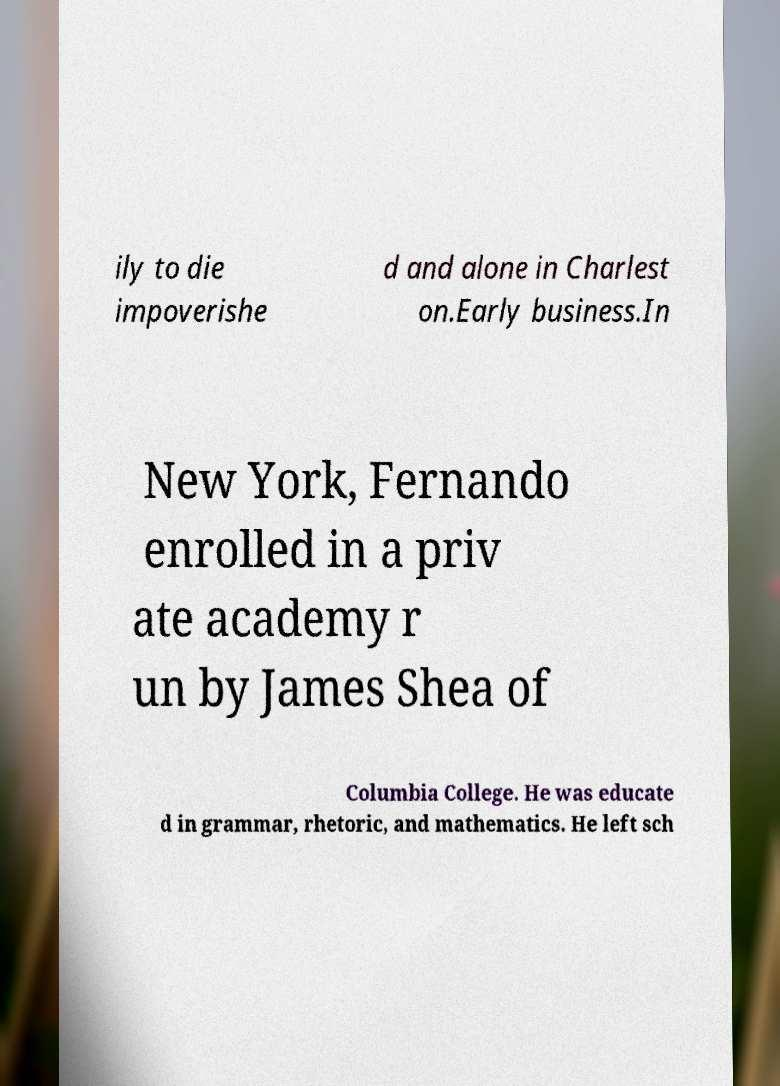What messages or text are displayed in this image? I need them in a readable, typed format. ily to die impoverishe d and alone in Charlest on.Early business.In New York, Fernando enrolled in a priv ate academy r un by James Shea of Columbia College. He was educate d in grammar, rhetoric, and mathematics. He left sch 